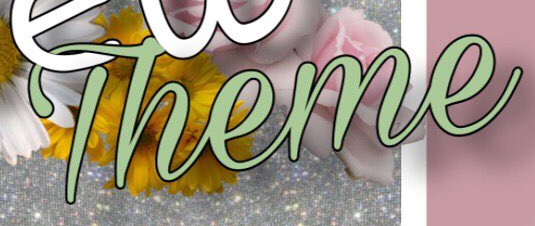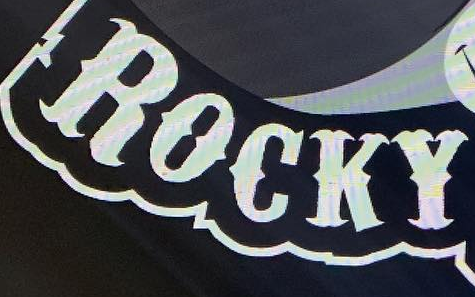Read the text content from these images in order, separated by a semicolon. Theme; ROCKY 